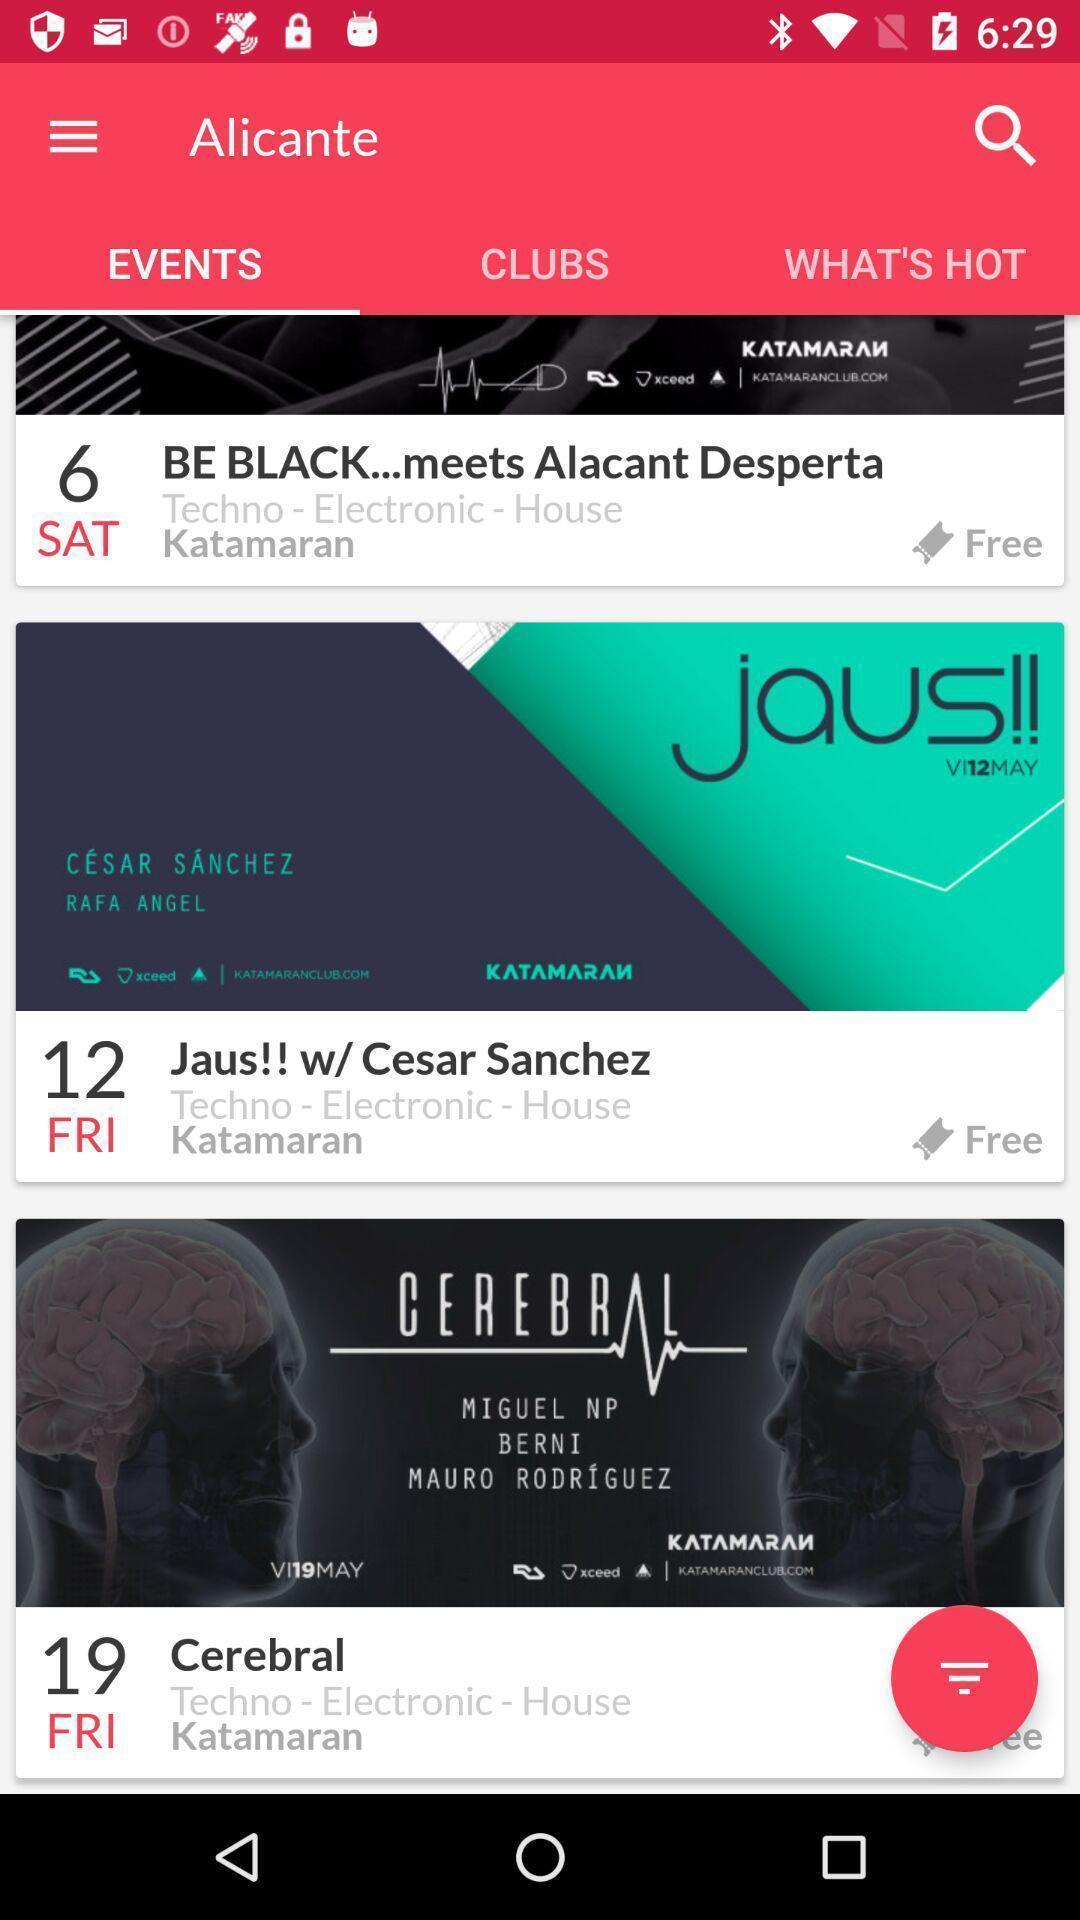Summarize the main components in this picture. Page showing events on a screen. 